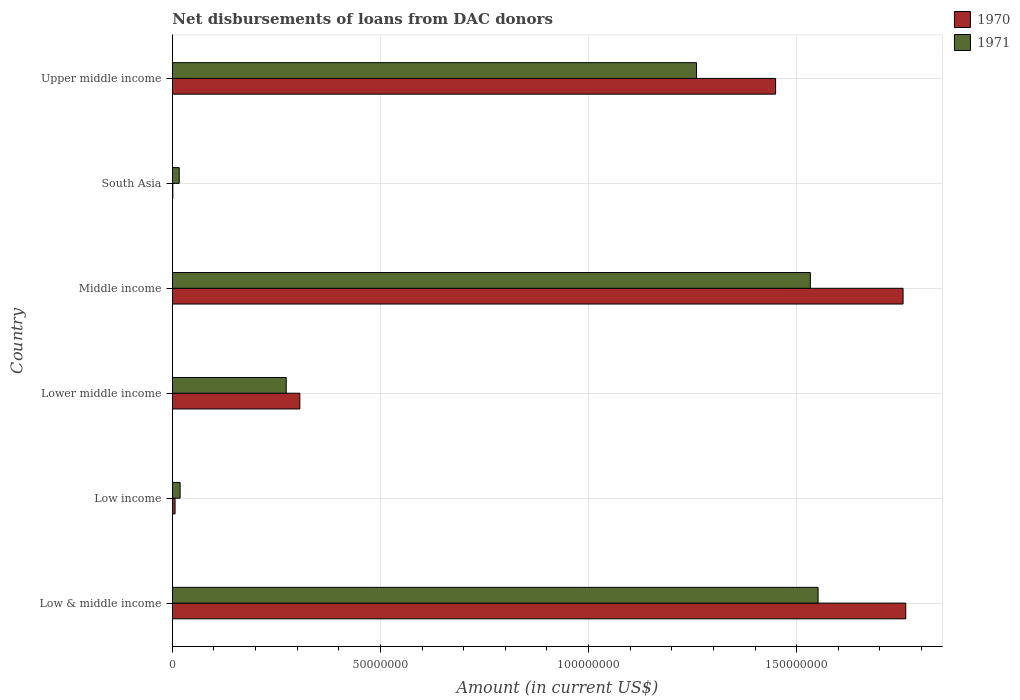How many different coloured bars are there?
Give a very brief answer. 2. Are the number of bars per tick equal to the number of legend labels?
Make the answer very short. Yes. How many bars are there on the 3rd tick from the top?
Provide a succinct answer. 2. How many bars are there on the 2nd tick from the bottom?
Provide a succinct answer. 2. What is the amount of loans disbursed in 1971 in Upper middle income?
Provide a short and direct response. 1.26e+08. Across all countries, what is the maximum amount of loans disbursed in 1971?
Your answer should be very brief. 1.55e+08. Across all countries, what is the minimum amount of loans disbursed in 1970?
Provide a succinct answer. 1.09e+05. What is the total amount of loans disbursed in 1971 in the graph?
Provide a succinct answer. 4.65e+08. What is the difference between the amount of loans disbursed in 1970 in Low & middle income and that in Low income?
Provide a succinct answer. 1.76e+08. What is the difference between the amount of loans disbursed in 1971 in Lower middle income and the amount of loans disbursed in 1970 in Low & middle income?
Offer a very short reply. -1.49e+08. What is the average amount of loans disbursed in 1971 per country?
Provide a short and direct response. 7.75e+07. What is the difference between the amount of loans disbursed in 1970 and amount of loans disbursed in 1971 in Low income?
Ensure brevity in your answer.  -1.21e+06. What is the ratio of the amount of loans disbursed in 1970 in Lower middle income to that in Middle income?
Your answer should be very brief. 0.17. What is the difference between the highest and the second highest amount of loans disbursed in 1970?
Ensure brevity in your answer.  6.47e+05. What is the difference between the highest and the lowest amount of loans disbursed in 1970?
Provide a succinct answer. 1.76e+08. In how many countries, is the amount of loans disbursed in 1970 greater than the average amount of loans disbursed in 1970 taken over all countries?
Provide a succinct answer. 3. What does the 1st bar from the bottom in South Asia represents?
Offer a very short reply. 1970. How many bars are there?
Give a very brief answer. 12. Are all the bars in the graph horizontal?
Offer a terse response. Yes. How many countries are there in the graph?
Offer a terse response. 6. What is the difference between two consecutive major ticks on the X-axis?
Ensure brevity in your answer.  5.00e+07. Does the graph contain any zero values?
Your answer should be very brief. No. What is the title of the graph?
Provide a succinct answer. Net disbursements of loans from DAC donors. Does "1982" appear as one of the legend labels in the graph?
Your answer should be very brief. No. What is the label or title of the X-axis?
Offer a very short reply. Amount (in current US$). What is the label or title of the Y-axis?
Make the answer very short. Country. What is the Amount (in current US$) in 1970 in Low & middle income?
Make the answer very short. 1.76e+08. What is the Amount (in current US$) in 1971 in Low & middle income?
Keep it short and to the point. 1.55e+08. What is the Amount (in current US$) of 1970 in Low income?
Your answer should be very brief. 6.47e+05. What is the Amount (in current US$) in 1971 in Low income?
Ensure brevity in your answer.  1.86e+06. What is the Amount (in current US$) in 1970 in Lower middle income?
Make the answer very short. 3.06e+07. What is the Amount (in current US$) of 1971 in Lower middle income?
Make the answer very short. 2.74e+07. What is the Amount (in current US$) in 1970 in Middle income?
Ensure brevity in your answer.  1.76e+08. What is the Amount (in current US$) in 1971 in Middle income?
Your response must be concise. 1.53e+08. What is the Amount (in current US$) of 1970 in South Asia?
Offer a very short reply. 1.09e+05. What is the Amount (in current US$) in 1971 in South Asia?
Your answer should be compact. 1.65e+06. What is the Amount (in current US$) in 1970 in Upper middle income?
Offer a terse response. 1.45e+08. What is the Amount (in current US$) of 1971 in Upper middle income?
Offer a very short reply. 1.26e+08. Across all countries, what is the maximum Amount (in current US$) in 1970?
Provide a short and direct response. 1.76e+08. Across all countries, what is the maximum Amount (in current US$) in 1971?
Provide a succinct answer. 1.55e+08. Across all countries, what is the minimum Amount (in current US$) of 1970?
Your response must be concise. 1.09e+05. Across all countries, what is the minimum Amount (in current US$) of 1971?
Your answer should be compact. 1.65e+06. What is the total Amount (in current US$) of 1970 in the graph?
Provide a succinct answer. 5.28e+08. What is the total Amount (in current US$) of 1971 in the graph?
Your response must be concise. 4.65e+08. What is the difference between the Amount (in current US$) of 1970 in Low & middle income and that in Low income?
Provide a short and direct response. 1.76e+08. What is the difference between the Amount (in current US$) in 1971 in Low & middle income and that in Low income?
Your answer should be very brief. 1.53e+08. What is the difference between the Amount (in current US$) of 1970 in Low & middle income and that in Lower middle income?
Give a very brief answer. 1.46e+08. What is the difference between the Amount (in current US$) of 1971 in Low & middle income and that in Lower middle income?
Provide a short and direct response. 1.28e+08. What is the difference between the Amount (in current US$) of 1970 in Low & middle income and that in Middle income?
Ensure brevity in your answer.  6.47e+05. What is the difference between the Amount (in current US$) in 1971 in Low & middle income and that in Middle income?
Provide a short and direct response. 1.86e+06. What is the difference between the Amount (in current US$) of 1970 in Low & middle income and that in South Asia?
Your answer should be compact. 1.76e+08. What is the difference between the Amount (in current US$) of 1971 in Low & middle income and that in South Asia?
Provide a short and direct response. 1.53e+08. What is the difference between the Amount (in current US$) of 1970 in Low & middle income and that in Upper middle income?
Your answer should be compact. 3.13e+07. What is the difference between the Amount (in current US$) in 1971 in Low & middle income and that in Upper middle income?
Offer a very short reply. 2.92e+07. What is the difference between the Amount (in current US$) in 1970 in Low income and that in Lower middle income?
Provide a short and direct response. -3.00e+07. What is the difference between the Amount (in current US$) of 1971 in Low income and that in Lower middle income?
Offer a very short reply. -2.55e+07. What is the difference between the Amount (in current US$) of 1970 in Low income and that in Middle income?
Your response must be concise. -1.75e+08. What is the difference between the Amount (in current US$) in 1971 in Low income and that in Middle income?
Your response must be concise. -1.51e+08. What is the difference between the Amount (in current US$) in 1970 in Low income and that in South Asia?
Offer a terse response. 5.38e+05. What is the difference between the Amount (in current US$) in 1971 in Low income and that in South Asia?
Your answer should be compact. 2.09e+05. What is the difference between the Amount (in current US$) of 1970 in Low income and that in Upper middle income?
Provide a short and direct response. -1.44e+08. What is the difference between the Amount (in current US$) of 1971 in Low income and that in Upper middle income?
Provide a succinct answer. -1.24e+08. What is the difference between the Amount (in current US$) in 1970 in Lower middle income and that in Middle income?
Your answer should be compact. -1.45e+08. What is the difference between the Amount (in current US$) of 1971 in Lower middle income and that in Middle income?
Keep it short and to the point. -1.26e+08. What is the difference between the Amount (in current US$) of 1970 in Lower middle income and that in South Asia?
Give a very brief answer. 3.05e+07. What is the difference between the Amount (in current US$) in 1971 in Lower middle income and that in South Asia?
Your answer should be compact. 2.57e+07. What is the difference between the Amount (in current US$) in 1970 in Lower middle income and that in Upper middle income?
Offer a very short reply. -1.14e+08. What is the difference between the Amount (in current US$) in 1971 in Lower middle income and that in Upper middle income?
Provide a short and direct response. -9.86e+07. What is the difference between the Amount (in current US$) in 1970 in Middle income and that in South Asia?
Your answer should be very brief. 1.75e+08. What is the difference between the Amount (in current US$) of 1971 in Middle income and that in South Asia?
Make the answer very short. 1.52e+08. What is the difference between the Amount (in current US$) in 1970 in Middle income and that in Upper middle income?
Provide a short and direct response. 3.06e+07. What is the difference between the Amount (in current US$) in 1971 in Middle income and that in Upper middle income?
Offer a very short reply. 2.74e+07. What is the difference between the Amount (in current US$) of 1970 in South Asia and that in Upper middle income?
Make the answer very short. -1.45e+08. What is the difference between the Amount (in current US$) of 1971 in South Asia and that in Upper middle income?
Provide a succinct answer. -1.24e+08. What is the difference between the Amount (in current US$) in 1970 in Low & middle income and the Amount (in current US$) in 1971 in Low income?
Offer a very short reply. 1.74e+08. What is the difference between the Amount (in current US$) of 1970 in Low & middle income and the Amount (in current US$) of 1971 in Lower middle income?
Provide a short and direct response. 1.49e+08. What is the difference between the Amount (in current US$) in 1970 in Low & middle income and the Amount (in current US$) in 1971 in Middle income?
Make the answer very short. 2.29e+07. What is the difference between the Amount (in current US$) of 1970 in Low & middle income and the Amount (in current US$) of 1971 in South Asia?
Provide a succinct answer. 1.75e+08. What is the difference between the Amount (in current US$) in 1970 in Low & middle income and the Amount (in current US$) in 1971 in Upper middle income?
Provide a succinct answer. 5.03e+07. What is the difference between the Amount (in current US$) in 1970 in Low income and the Amount (in current US$) in 1971 in Lower middle income?
Ensure brevity in your answer.  -2.67e+07. What is the difference between the Amount (in current US$) of 1970 in Low income and the Amount (in current US$) of 1971 in Middle income?
Ensure brevity in your answer.  -1.53e+08. What is the difference between the Amount (in current US$) of 1970 in Low income and the Amount (in current US$) of 1971 in South Asia?
Ensure brevity in your answer.  -1.00e+06. What is the difference between the Amount (in current US$) of 1970 in Low income and the Amount (in current US$) of 1971 in Upper middle income?
Make the answer very short. -1.25e+08. What is the difference between the Amount (in current US$) of 1970 in Lower middle income and the Amount (in current US$) of 1971 in Middle income?
Offer a terse response. -1.23e+08. What is the difference between the Amount (in current US$) in 1970 in Lower middle income and the Amount (in current US$) in 1971 in South Asia?
Provide a succinct answer. 2.90e+07. What is the difference between the Amount (in current US$) of 1970 in Lower middle income and the Amount (in current US$) of 1971 in Upper middle income?
Your response must be concise. -9.53e+07. What is the difference between the Amount (in current US$) in 1970 in Middle income and the Amount (in current US$) in 1971 in South Asia?
Your response must be concise. 1.74e+08. What is the difference between the Amount (in current US$) in 1970 in Middle income and the Amount (in current US$) in 1971 in Upper middle income?
Ensure brevity in your answer.  4.96e+07. What is the difference between the Amount (in current US$) in 1970 in South Asia and the Amount (in current US$) in 1971 in Upper middle income?
Keep it short and to the point. -1.26e+08. What is the average Amount (in current US$) of 1970 per country?
Offer a very short reply. 8.80e+07. What is the average Amount (in current US$) of 1971 per country?
Provide a succinct answer. 7.75e+07. What is the difference between the Amount (in current US$) of 1970 and Amount (in current US$) of 1971 in Low & middle income?
Your answer should be very brief. 2.11e+07. What is the difference between the Amount (in current US$) in 1970 and Amount (in current US$) in 1971 in Low income?
Offer a very short reply. -1.21e+06. What is the difference between the Amount (in current US$) in 1970 and Amount (in current US$) in 1971 in Lower middle income?
Offer a very short reply. 3.27e+06. What is the difference between the Amount (in current US$) in 1970 and Amount (in current US$) in 1971 in Middle income?
Offer a terse response. 2.23e+07. What is the difference between the Amount (in current US$) in 1970 and Amount (in current US$) in 1971 in South Asia?
Offer a terse response. -1.54e+06. What is the difference between the Amount (in current US$) of 1970 and Amount (in current US$) of 1971 in Upper middle income?
Your answer should be compact. 1.90e+07. What is the ratio of the Amount (in current US$) in 1970 in Low & middle income to that in Low income?
Keep it short and to the point. 272.33. What is the ratio of the Amount (in current US$) in 1971 in Low & middle income to that in Low income?
Give a very brief answer. 83.45. What is the ratio of the Amount (in current US$) in 1970 in Low & middle income to that in Lower middle income?
Give a very brief answer. 5.75. What is the ratio of the Amount (in current US$) in 1971 in Low & middle income to that in Lower middle income?
Give a very brief answer. 5.67. What is the ratio of the Amount (in current US$) of 1970 in Low & middle income to that in Middle income?
Keep it short and to the point. 1. What is the ratio of the Amount (in current US$) in 1971 in Low & middle income to that in Middle income?
Offer a terse response. 1.01. What is the ratio of the Amount (in current US$) of 1970 in Low & middle income to that in South Asia?
Your answer should be compact. 1616.51. What is the ratio of the Amount (in current US$) of 1971 in Low & middle income to that in South Asia?
Your response must be concise. 94.02. What is the ratio of the Amount (in current US$) in 1970 in Low & middle income to that in Upper middle income?
Provide a short and direct response. 1.22. What is the ratio of the Amount (in current US$) of 1971 in Low & middle income to that in Upper middle income?
Offer a terse response. 1.23. What is the ratio of the Amount (in current US$) of 1970 in Low income to that in Lower middle income?
Your answer should be compact. 0.02. What is the ratio of the Amount (in current US$) in 1971 in Low income to that in Lower middle income?
Your response must be concise. 0.07. What is the ratio of the Amount (in current US$) in 1970 in Low income to that in Middle income?
Keep it short and to the point. 0. What is the ratio of the Amount (in current US$) in 1971 in Low income to that in Middle income?
Your answer should be very brief. 0.01. What is the ratio of the Amount (in current US$) in 1970 in Low income to that in South Asia?
Your answer should be very brief. 5.94. What is the ratio of the Amount (in current US$) in 1971 in Low income to that in South Asia?
Ensure brevity in your answer.  1.13. What is the ratio of the Amount (in current US$) of 1970 in Low income to that in Upper middle income?
Keep it short and to the point. 0. What is the ratio of the Amount (in current US$) in 1971 in Low income to that in Upper middle income?
Provide a short and direct response. 0.01. What is the ratio of the Amount (in current US$) in 1970 in Lower middle income to that in Middle income?
Offer a very short reply. 0.17. What is the ratio of the Amount (in current US$) of 1971 in Lower middle income to that in Middle income?
Make the answer very short. 0.18. What is the ratio of the Amount (in current US$) in 1970 in Lower middle income to that in South Asia?
Keep it short and to the point. 280.94. What is the ratio of the Amount (in current US$) of 1971 in Lower middle income to that in South Asia?
Provide a short and direct response. 16.58. What is the ratio of the Amount (in current US$) of 1970 in Lower middle income to that in Upper middle income?
Give a very brief answer. 0.21. What is the ratio of the Amount (in current US$) in 1971 in Lower middle income to that in Upper middle income?
Ensure brevity in your answer.  0.22. What is the ratio of the Amount (in current US$) in 1970 in Middle income to that in South Asia?
Ensure brevity in your answer.  1610.58. What is the ratio of the Amount (in current US$) in 1971 in Middle income to that in South Asia?
Your answer should be compact. 92.89. What is the ratio of the Amount (in current US$) in 1970 in Middle income to that in Upper middle income?
Keep it short and to the point. 1.21. What is the ratio of the Amount (in current US$) in 1971 in Middle income to that in Upper middle income?
Keep it short and to the point. 1.22. What is the ratio of the Amount (in current US$) in 1970 in South Asia to that in Upper middle income?
Your response must be concise. 0. What is the ratio of the Amount (in current US$) of 1971 in South Asia to that in Upper middle income?
Make the answer very short. 0.01. What is the difference between the highest and the second highest Amount (in current US$) of 1970?
Your answer should be very brief. 6.47e+05. What is the difference between the highest and the second highest Amount (in current US$) of 1971?
Make the answer very short. 1.86e+06. What is the difference between the highest and the lowest Amount (in current US$) in 1970?
Provide a short and direct response. 1.76e+08. What is the difference between the highest and the lowest Amount (in current US$) in 1971?
Make the answer very short. 1.53e+08. 